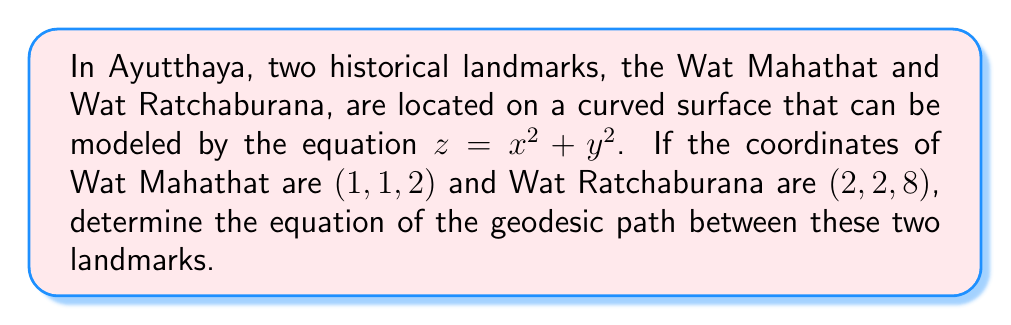Solve this math problem. To find the geodesic path between the two landmarks, we need to follow these steps:

1) First, we parametrize the surface. Let $\mathbf{r}(u, v) = (u, v, u^2 + v^2)$ be our parametrization.

2) The metric tensor $g_{ij}$ is given by:
   $$g_{11} = 1 + 4u^2, \quad g_{12} = g_{21} = 4uv, \quad g_{22} = 1 + 4v^2$$

3) The Christoffel symbols are:
   $$\Gamma_{11}^1 = \frac{2u}{1+4u^2}, \quad \Gamma_{11}^2 = -\frac{2v}{1+4v^2}$$
   $$\Gamma_{12}^1 = \Gamma_{21}^1 = \frac{2v}{1+4u^2}, \quad \Gamma_{12}^2 = \Gamma_{21}^2 = \frac{2u}{1+4v^2}$$
   $$\Gamma_{22}^1 = -\frac{2u}{1+4u^2}, \quad \Gamma_{22}^2 = \frac{2v}{1+4v^2}$$

4) The geodesic equations are:
   $$\frac{d^2u}{dt^2} + \Gamma_{11}^1(\frac{du}{dt})^2 + 2\Gamma_{12}^1\frac{du}{dt}\frac{dv}{dt} + \Gamma_{22}^1(\frac{dv}{dt})^2 = 0$$
   $$\frac{d^2v}{dt^2} + \Gamma_{11}^2(\frac{du}{dt})^2 + 2\Gamma_{12}^2\frac{du}{dt}\frac{dv}{dt} + \Gamma_{22}^2(\frac{dv}{dt})^2 = 0$$

5) Substituting the Christoffel symbols:
   $$\frac{d^2u}{dt^2} + \frac{2u}{1+4u^2}(\frac{du}{dt})^2 + \frac{4v}{1+4u^2}\frac{du}{dt}\frac{dv}{dt} - \frac{2u}{1+4u^2}(\frac{dv}{dt})^2 = 0$$
   $$\frac{d^2v}{dt^2} - \frac{2v}{1+4v^2}(\frac{du}{dt})^2 + \frac{4u}{1+4v^2}\frac{du}{dt}\frac{dv}{dt} + \frac{2v}{1+4v^2}(\frac{dv}{dt})^2 = 0$$

6) These differential equations describe the geodesic path between the two landmarks. The solution to these equations, with the given boundary conditions $(u(0), v(0)) = (1, 1)$ and $(u(1), v(1)) = (2, 2)$, will give the equation of the geodesic path.

Due to the complexity of these equations, an exact analytical solution is not easily obtainable. Numerical methods would typically be used to solve this system of differential equations.
Answer: The geodesic path is described by the system of differential equations:

$$\frac{d^2u}{dt^2} + \frac{2u}{1+4u^2}(\frac{du}{dt})^2 + \frac{4v}{1+4u^2}\frac{du}{dt}\frac{dv}{dt} - \frac{2u}{1+4u^2}(\frac{dv}{dt})^2 = 0$$
$$\frac{d^2v}{dt^2} - \frac{2v}{1+4v^2}(\frac{du}{dt})^2 + \frac{4u}{1+4v^2}\frac{du}{dt}\frac{dv}{dt} + \frac{2v}{1+4v^2}(\frac{dv}{dt})^2 = 0$$ 